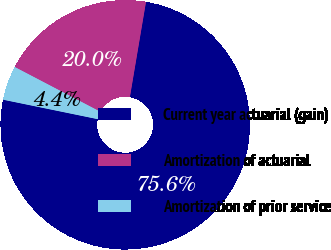Convert chart. <chart><loc_0><loc_0><loc_500><loc_500><pie_chart><fcel>Current year actuarial (gain)<fcel>Amortization of actuarial<fcel>Amortization of prior service<nl><fcel>75.56%<fcel>20.0%<fcel>4.44%<nl></chart> 